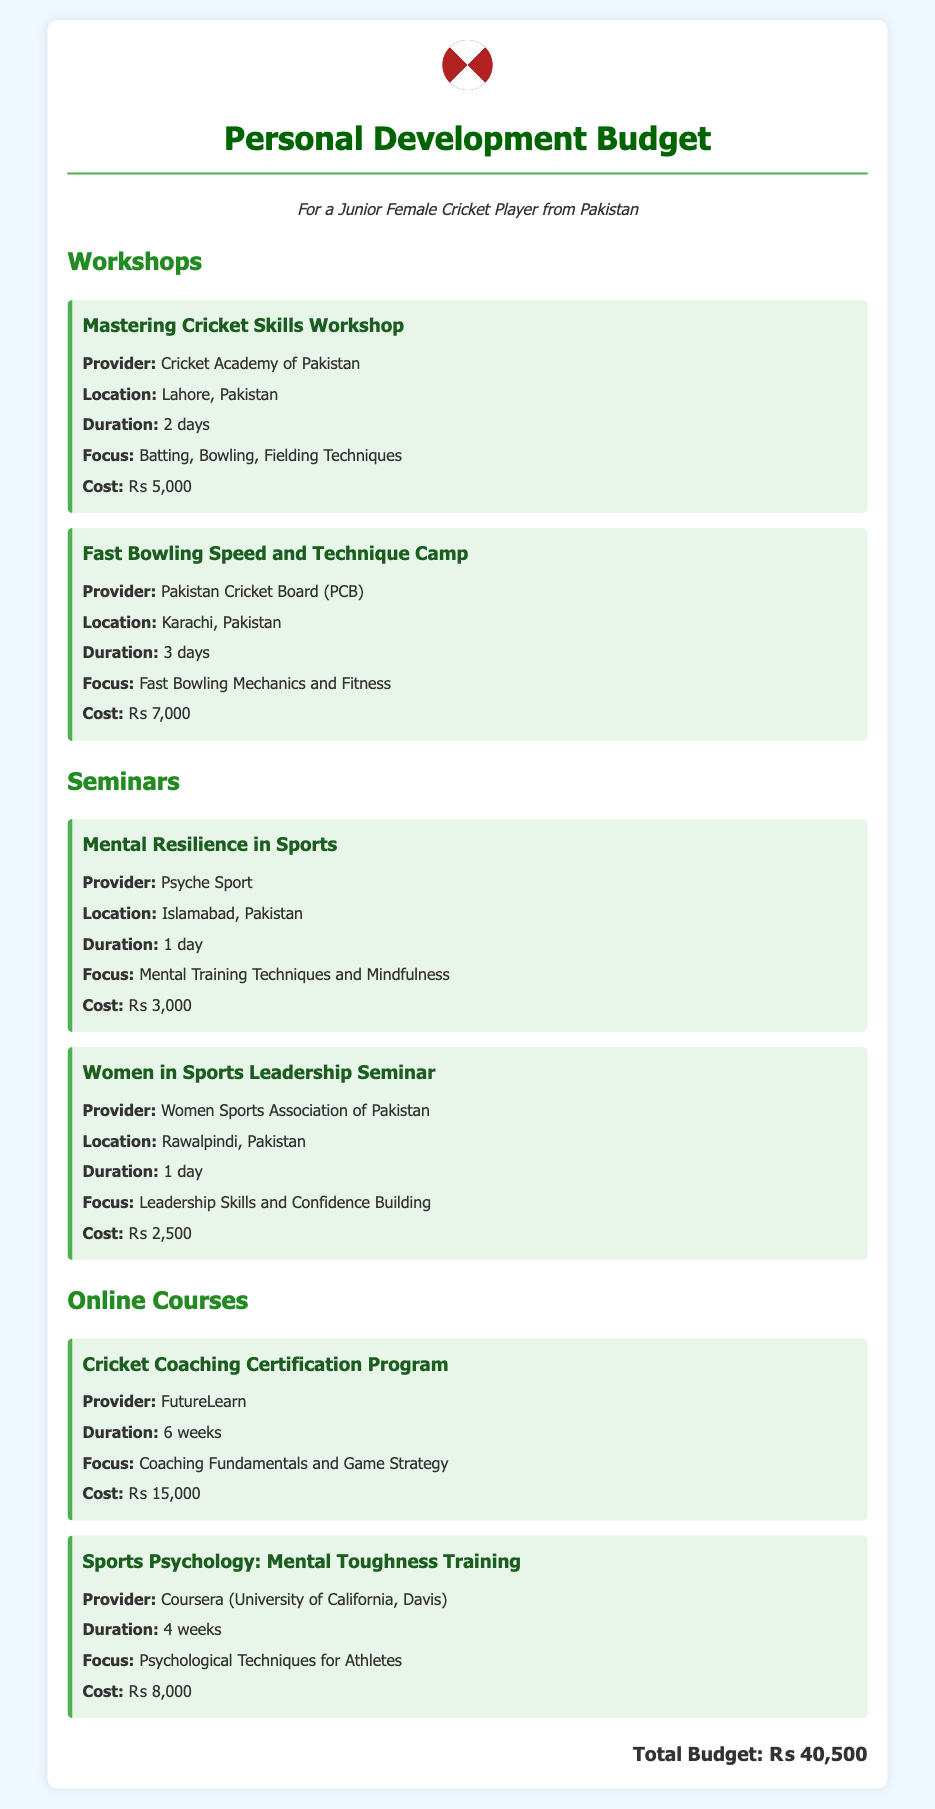What is the cost of the Mastering Cricket Skills Workshop? The cost is listed clearly under the workshop section for this item.
Answer: ₨ 5,000 Who provides the Fast Bowling Speed and Technique Camp? The provider’s name is mentioned directly under the workshop title.
Answer: Pakistan Cricket Board (PCB) What is the focus of the Mental Resilience in Sports seminar? The focus is specified in the seminar description just after mentioning the title.
Answer: Mental Training Techniques and Mindfulness How long is the Cricket Coaching Certification Program? The duration, found under the online course section, indicates how long the program lasts.
Answer: 6 weeks What is the total budget for personal development? The total budget is tallied at the end of the document summarizing all costs listed.
Answer: ₨ 40,500 Which city hosts the Women in Sports Leadership Seminar? The location is provided in the seminar details beneath the title.
Answer: Rawalpindi How many days does the Fast Bowling Speed and Technique Camp last? The duration is clearly mentioned in the camp description.
Answer: 3 days What is the cost of the Sports Psychology course? The cost appears in the online course section for that specific course.
Answer: ₨ 8,000 